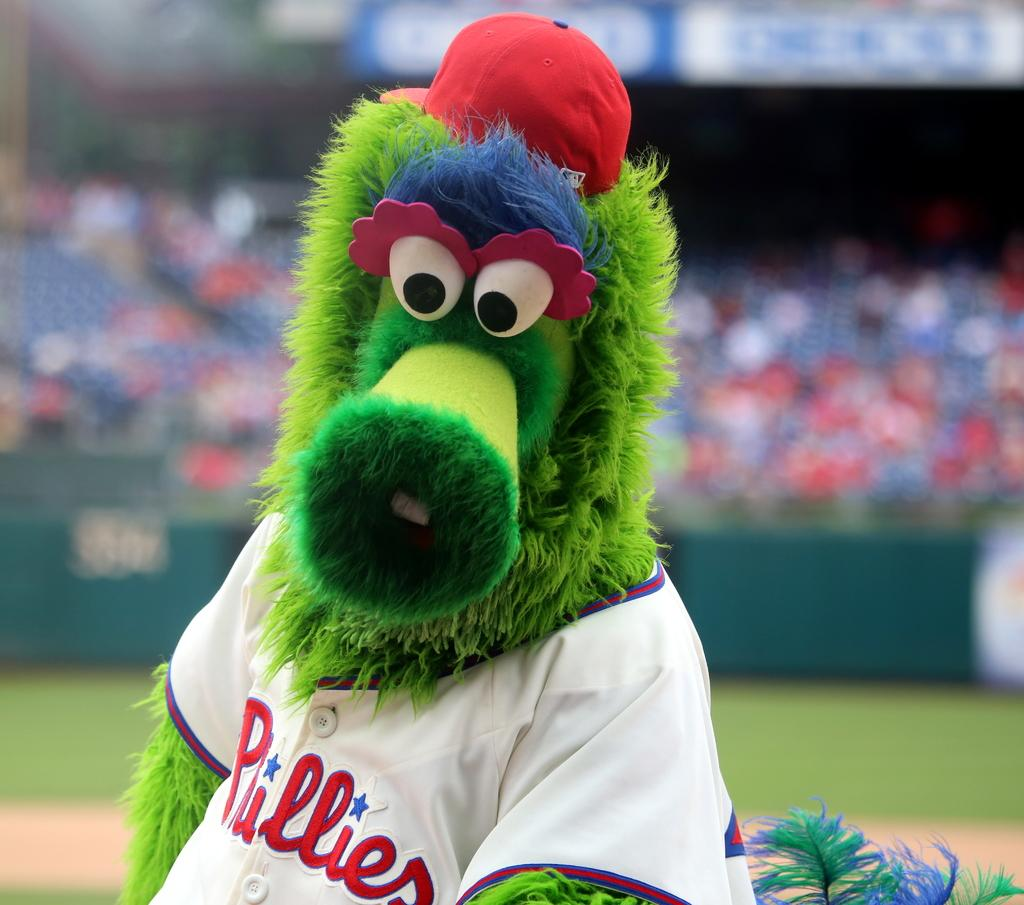<image>
Render a clear and concise summary of the photo. A sports mascot with a green fuzzy face and a tee shirt reading pullers. 